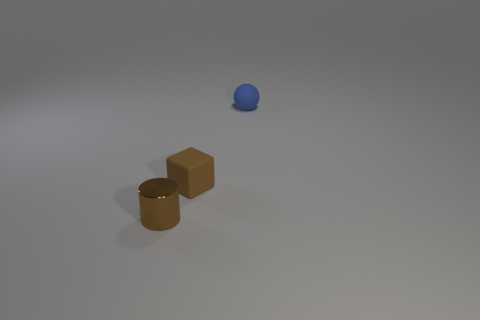Add 1 large blue blocks. How many objects exist? 4 Subtract all cubes. How many objects are left? 2 Subtract all brown rubber cubes. Subtract all small blue matte things. How many objects are left? 1 Add 1 small brown cylinders. How many small brown cylinders are left? 2 Add 1 red shiny balls. How many red shiny balls exist? 1 Subtract 0 gray spheres. How many objects are left? 3 